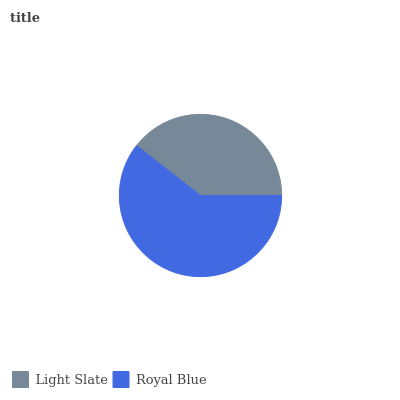Is Light Slate the minimum?
Answer yes or no. Yes. Is Royal Blue the maximum?
Answer yes or no. Yes. Is Royal Blue the minimum?
Answer yes or no. No. Is Royal Blue greater than Light Slate?
Answer yes or no. Yes. Is Light Slate less than Royal Blue?
Answer yes or no. Yes. Is Light Slate greater than Royal Blue?
Answer yes or no. No. Is Royal Blue less than Light Slate?
Answer yes or no. No. Is Royal Blue the high median?
Answer yes or no. Yes. Is Light Slate the low median?
Answer yes or no. Yes. Is Light Slate the high median?
Answer yes or no. No. Is Royal Blue the low median?
Answer yes or no. No. 